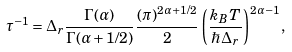Convert formula to latex. <formula><loc_0><loc_0><loc_500><loc_500>\tau ^ { - 1 } = \Delta _ { r } \frac { \Gamma ( \alpha ) } { \Gamma ( \alpha + 1 / 2 ) } \frac { ( \pi ) ^ { 2 \alpha + 1 / 2 } } { 2 } \left ( \frac { k _ { B } T } { \hbar { \Delta } _ { r } } \right ) ^ { 2 \alpha - 1 } ,</formula> 